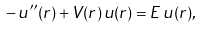<formula> <loc_0><loc_0><loc_500><loc_500>- \, u ^ { \prime \prime } ( r ) + V ( r ) \, u ( r ) = E \, u ( r ) ,</formula> 